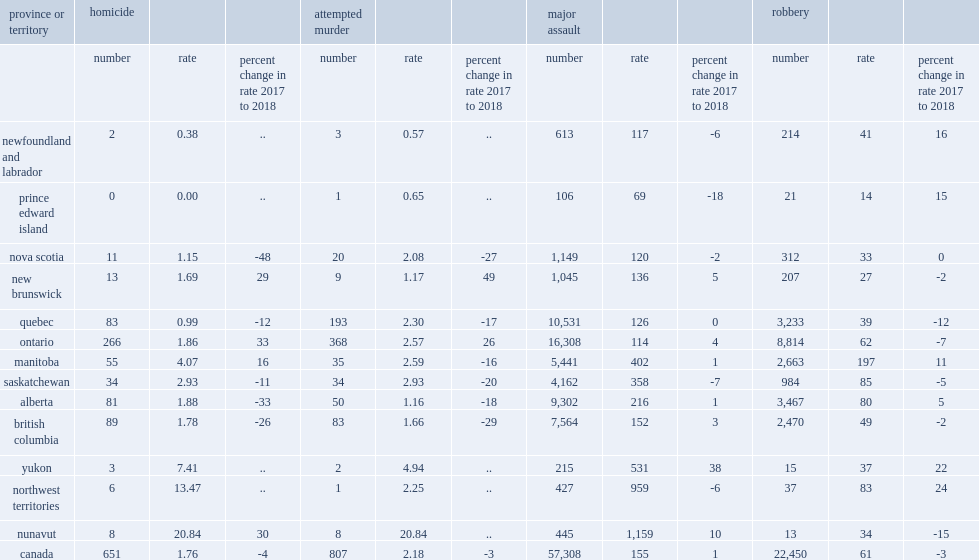What was the percent of the attempted murder rate in canada decreased between 2017 and 2018? 3. How many people per 100,000 population did the attempted murder rate in canada decrease? 2.18. 